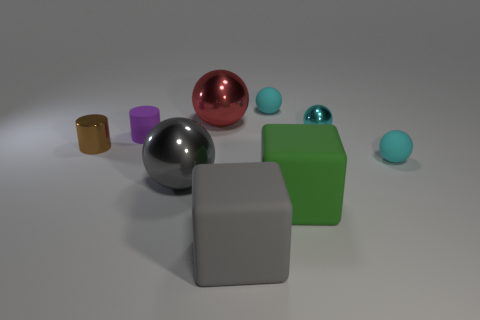What number of blue objects are either tiny cylinders or big things?
Make the answer very short. 0. Are there any things that have the same color as the tiny metallic sphere?
Provide a succinct answer. Yes. There is a purple cylinder that is made of the same material as the large green thing; what is its size?
Offer a very short reply. Small. What number of cylinders are either gray things or small cyan objects?
Make the answer very short. 0. Are there more spheres than tiny cylinders?
Keep it short and to the point. Yes. What number of cyan rubber things have the same size as the cyan metal object?
Offer a terse response. 2. How many things are either large cubes right of the gray cube or tiny rubber things?
Offer a very short reply. 4. Are there fewer green matte blocks than blue cylinders?
Offer a terse response. No. What is the shape of the other large object that is made of the same material as the large green thing?
Ensure brevity in your answer.  Cube. There is a brown metallic cylinder; are there any big red things behind it?
Provide a succinct answer. Yes. 